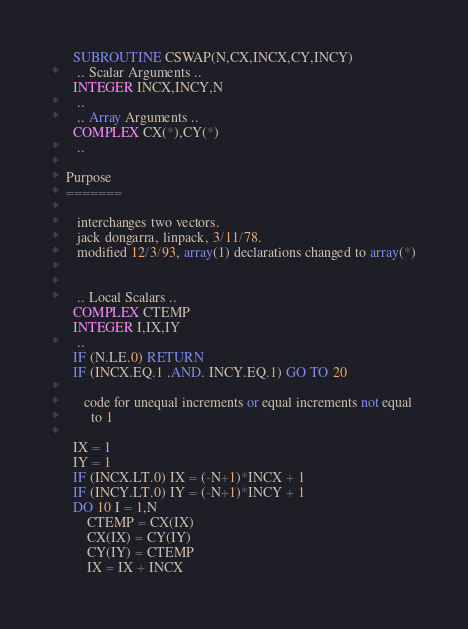<code> <loc_0><loc_0><loc_500><loc_500><_FORTRAN_>      SUBROUTINE CSWAP(N,CX,INCX,CY,INCY)
*     .. Scalar Arguments ..
      INTEGER INCX,INCY,N
*     ..
*     .. Array Arguments ..
      COMPLEX CX(*),CY(*)
*     ..
*
*  Purpose
*  =======
*
*     interchanges two vectors.
*     jack dongarra, linpack, 3/11/78.
*     modified 12/3/93, array(1) declarations changed to array(*)
*
*
*     .. Local Scalars ..
      COMPLEX CTEMP
      INTEGER I,IX,IY
*     ..
      IF (N.LE.0) RETURN
      IF (INCX.EQ.1 .AND. INCY.EQ.1) GO TO 20
*
*       code for unequal increments or equal increments not equal
*         to 1
*
      IX = 1
      IY = 1
      IF (INCX.LT.0) IX = (-N+1)*INCX + 1
      IF (INCY.LT.0) IY = (-N+1)*INCY + 1
      DO 10 I = 1,N
          CTEMP = CX(IX)
          CX(IX) = CY(IY)
          CY(IY) = CTEMP
          IX = IX + INCX</code> 